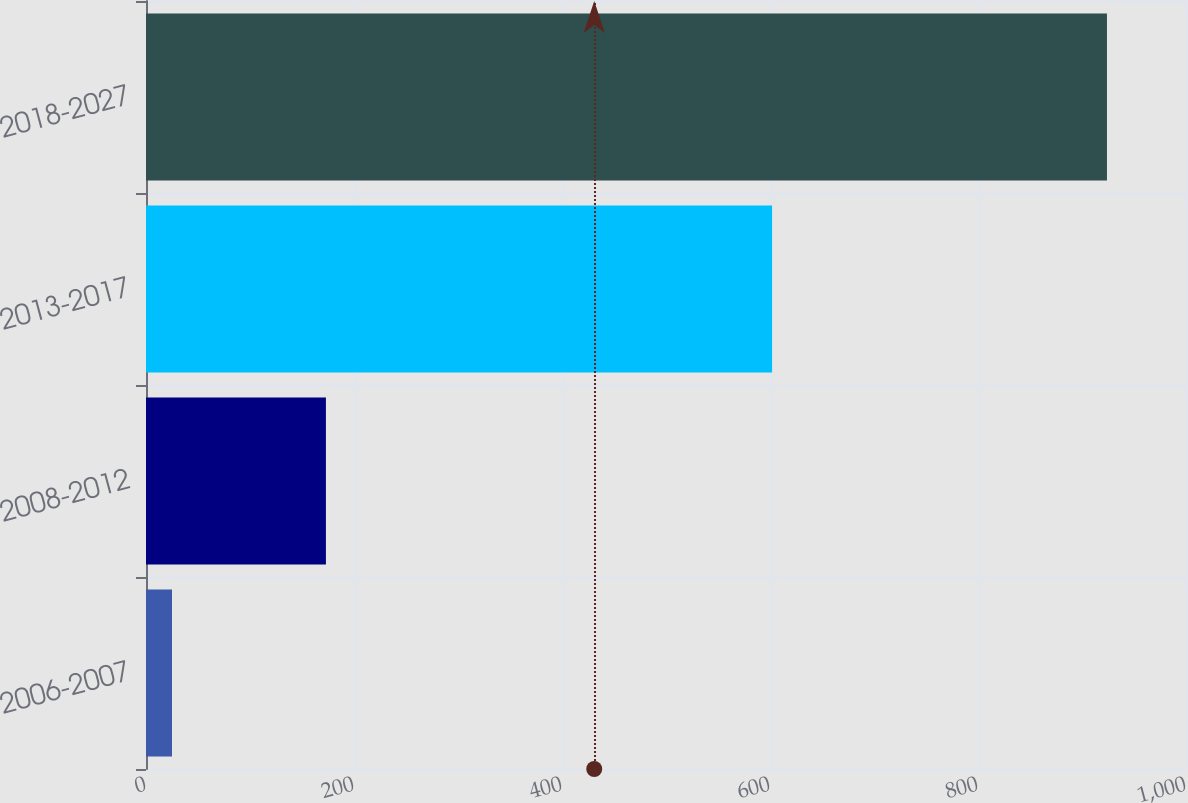<chart> <loc_0><loc_0><loc_500><loc_500><bar_chart><fcel>2006-2007<fcel>2008-2012<fcel>2013-2017<fcel>2018-2027<nl><fcel>25<fcel>173<fcel>602<fcel>924<nl></chart> 